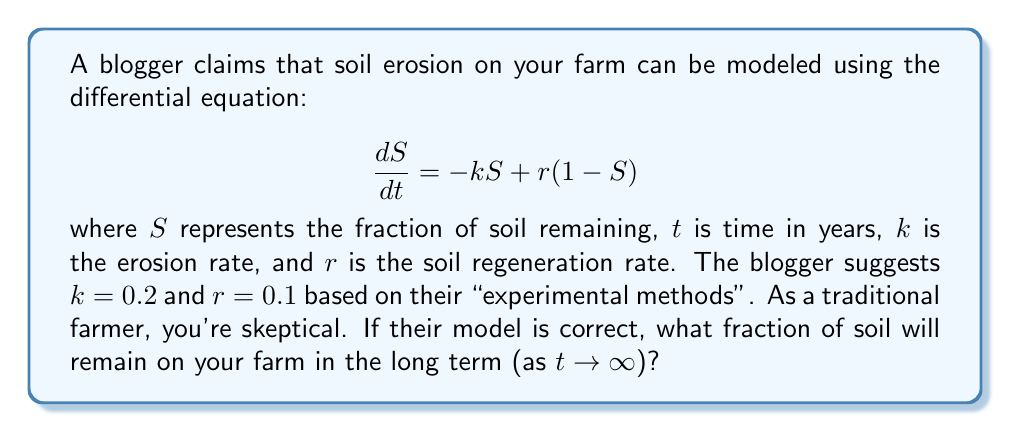Teach me how to tackle this problem. Let's approach this step-by-step:

1) First, we need to find the equilibrium point(s) of the system. At equilibrium, $\frac{dS}{dt} = 0$. So:

   $$0 = -kS + r(1-S)$$

2) Rearranging the equation:

   $$0 = -kS + r - rS = -S(k+r) + r$$

3) Solving for S:

   $$S(k+r) = r$$
   $$S = \frac{r}{k+r}$$

4) This is the long-term equilibrium value of S as $t \to \infty$.

5) Substituting the given values $k=0.2$ and $r=0.1$:

   $$S = \frac{0.1}{0.2+0.1} = \frac{0.1}{0.3} = \frac{1}{3}$$

6) Therefore, if the blogger's model and parameter estimates are correct, in the long term, 1/3 of the soil will remain.

As a traditional farmer, you might be skeptical of this result and question the blogger's methods for determining $k$ and $r$. You might also consider that this simple model doesn't account for many factors that you know affect soil erosion and regeneration on your farm.
Answer: $\frac{1}{3}$ 